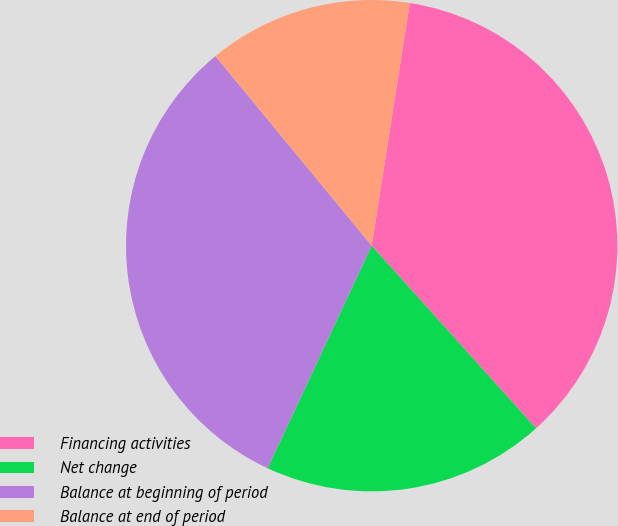<chart> <loc_0><loc_0><loc_500><loc_500><pie_chart><fcel>Financing activities<fcel>Net change<fcel>Balance at beginning of period<fcel>Balance at end of period<nl><fcel>35.86%<fcel>18.62%<fcel>32.07%<fcel>13.45%<nl></chart> 